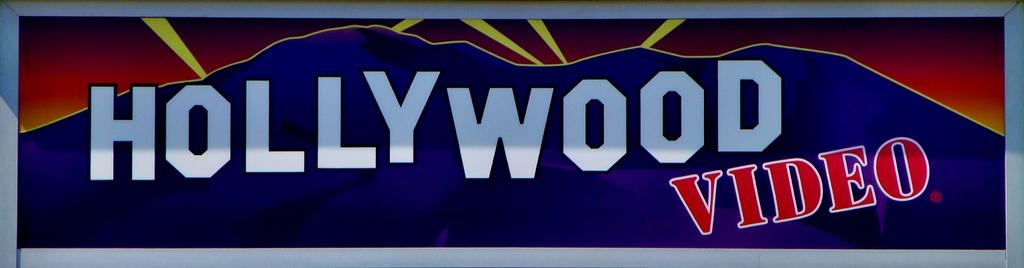What type of video is mentioned?
Your response must be concise. Hollywood. What is the name in white?
Provide a short and direct response. Hollywood. 